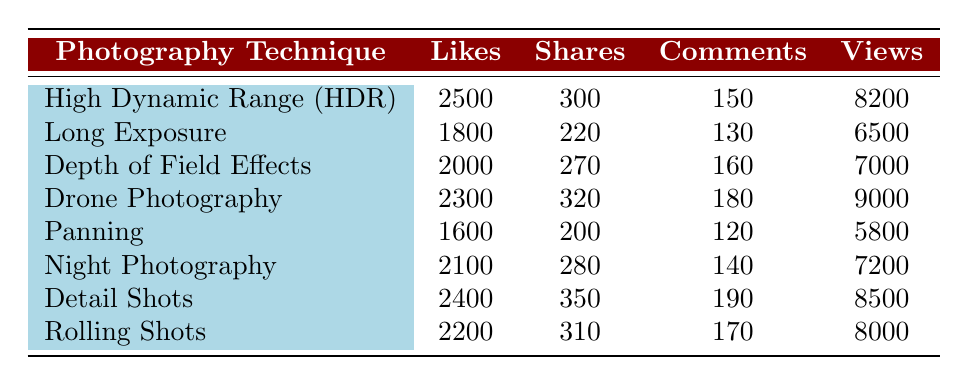What photography technique received the most likes? By looking at the "Likes" column, we find that "High Dynamic Range (HDR)" has the highest number of likes at 2500.
Answer: High Dynamic Range (HDR) Which photography technique has the lowest number of shares? From the "Shares" column, "Panning" shows the lowest number of shares, totaling 200.
Answer: Panning What is the combined total of likes for "Detail Shots" and "Rolling Shots"? Adding the likes of "Detail Shots" (2400) and "Rolling Shots" (2200) gives a total of 2400 + 2200 = 4600.
Answer: 4600 Is it true that "Drone Photography" received more views than "Night Photography"? Comparing the "Views" column, "Drone Photography" has 9000 views, while "Night Photography" has 7200 views. Since 9000 is greater than 7200, the statement is true.
Answer: True What is the difference in comments between the photography techniques with the highest and lowest comments? The highest comments are for "Detail Shots" (190), and the lowest are for "Panning" (120). Calculating the difference gives 190 - 120 = 70.
Answer: 70 Which photography technique received more shares: "Long Exposure" or "Depth of Field Effects"? Checking the "Shares" column, "Long Exposure" has 220 shares, while "Depth of Field Effects" has 270 shares. Since 270 is greater than 220, "Depth of Field Effects" received more shares.
Answer: Depth of Field Effects What is the average number of likes across all photography techniques? To find the average, sum up all the likes: 2500 + 1800 + 2000 + 2300 + 1600 + 2100 + 2400 + 2200 = 18400. Then, divide by the number of techniques, which is 8: 18400/8 = 2300.
Answer: 2300 Which photography technique has the highest number of views and how many views did it have? The "Views" column indicates that "Drone Photography" has the highest views with 9000.
Answer: Drone Photography, 9000 What is the median number of likes from the photography techniques listed? To find the median, we first list the likes in order: 1600, 1800, 2000, 2100, 2200, 2400, 2500, 2300. With 8 values, the median is the average of the 4th and 5th values: (2100 + 2200)/2 = 2150.
Answer: 2150 